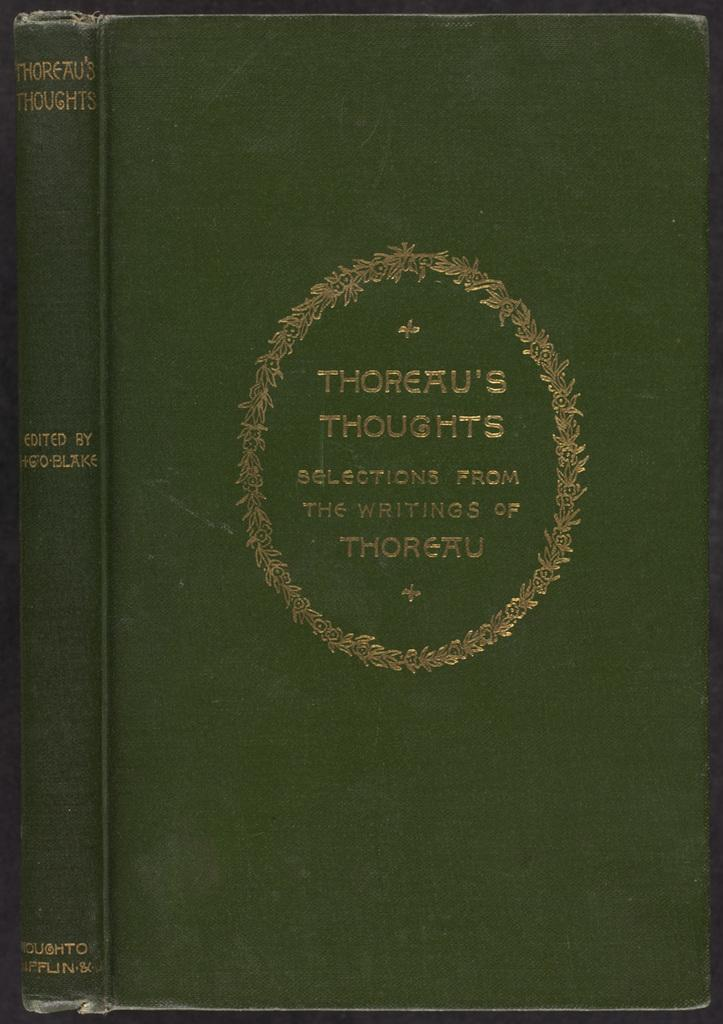<image>
Provide a brief description of the given image. A copy of Thoreau's Thoughts: Selections From The Writings Of Thoreau. 